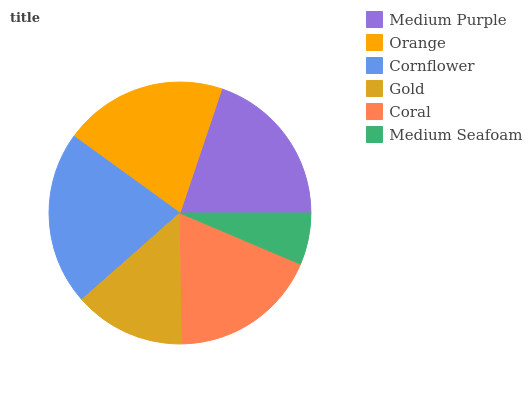Is Medium Seafoam the minimum?
Answer yes or no. Yes. Is Cornflower the maximum?
Answer yes or no. Yes. Is Orange the minimum?
Answer yes or no. No. Is Orange the maximum?
Answer yes or no. No. Is Orange greater than Medium Purple?
Answer yes or no. Yes. Is Medium Purple less than Orange?
Answer yes or no. Yes. Is Medium Purple greater than Orange?
Answer yes or no. No. Is Orange less than Medium Purple?
Answer yes or no. No. Is Medium Purple the high median?
Answer yes or no. Yes. Is Coral the low median?
Answer yes or no. Yes. Is Gold the high median?
Answer yes or no. No. Is Gold the low median?
Answer yes or no. No. 